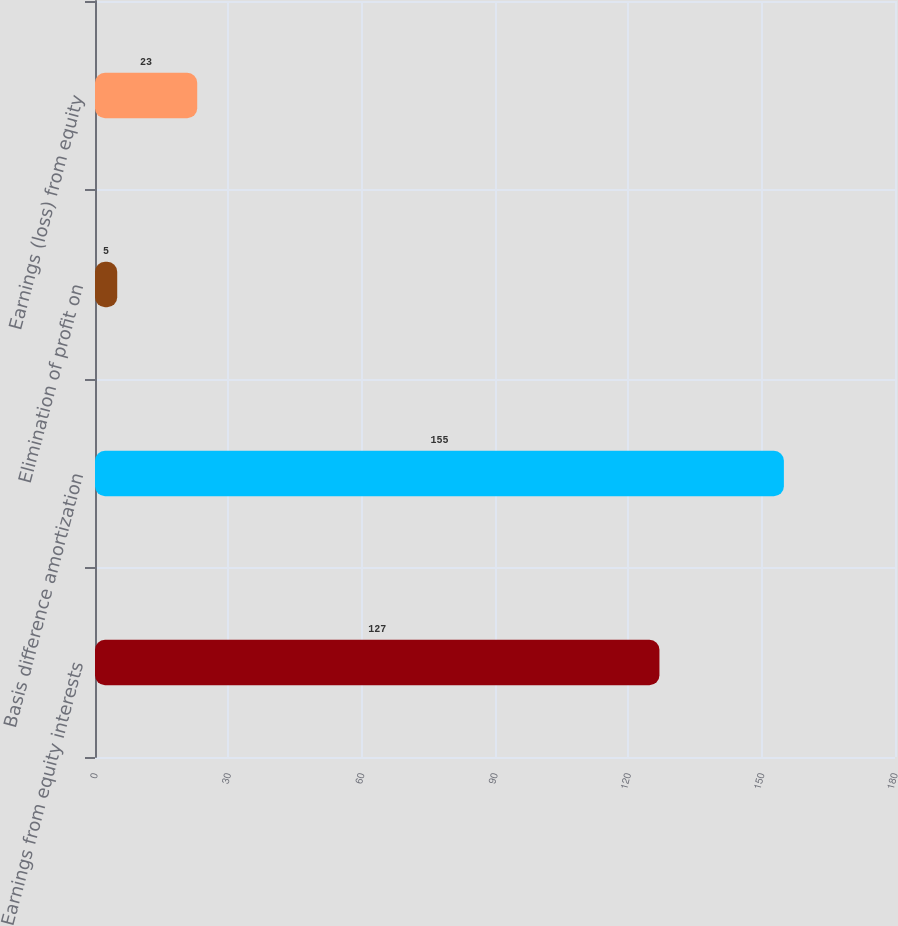Convert chart to OTSL. <chart><loc_0><loc_0><loc_500><loc_500><bar_chart><fcel>Earnings from equity interests<fcel>Basis difference amortization<fcel>Elimination of profit on<fcel>Earnings (loss) from equity<nl><fcel>127<fcel>155<fcel>5<fcel>23<nl></chart> 